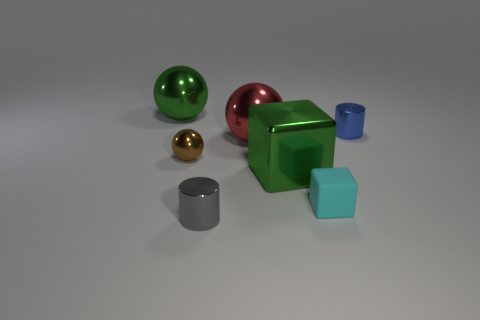Add 1 small green balls. How many objects exist? 8 Subtract all cylinders. How many objects are left? 5 Add 2 big green things. How many big green things are left? 4 Add 7 green metal things. How many green metal things exist? 9 Subtract 0 red cubes. How many objects are left? 7 Subtract all matte cubes. Subtract all large red shiny things. How many objects are left? 5 